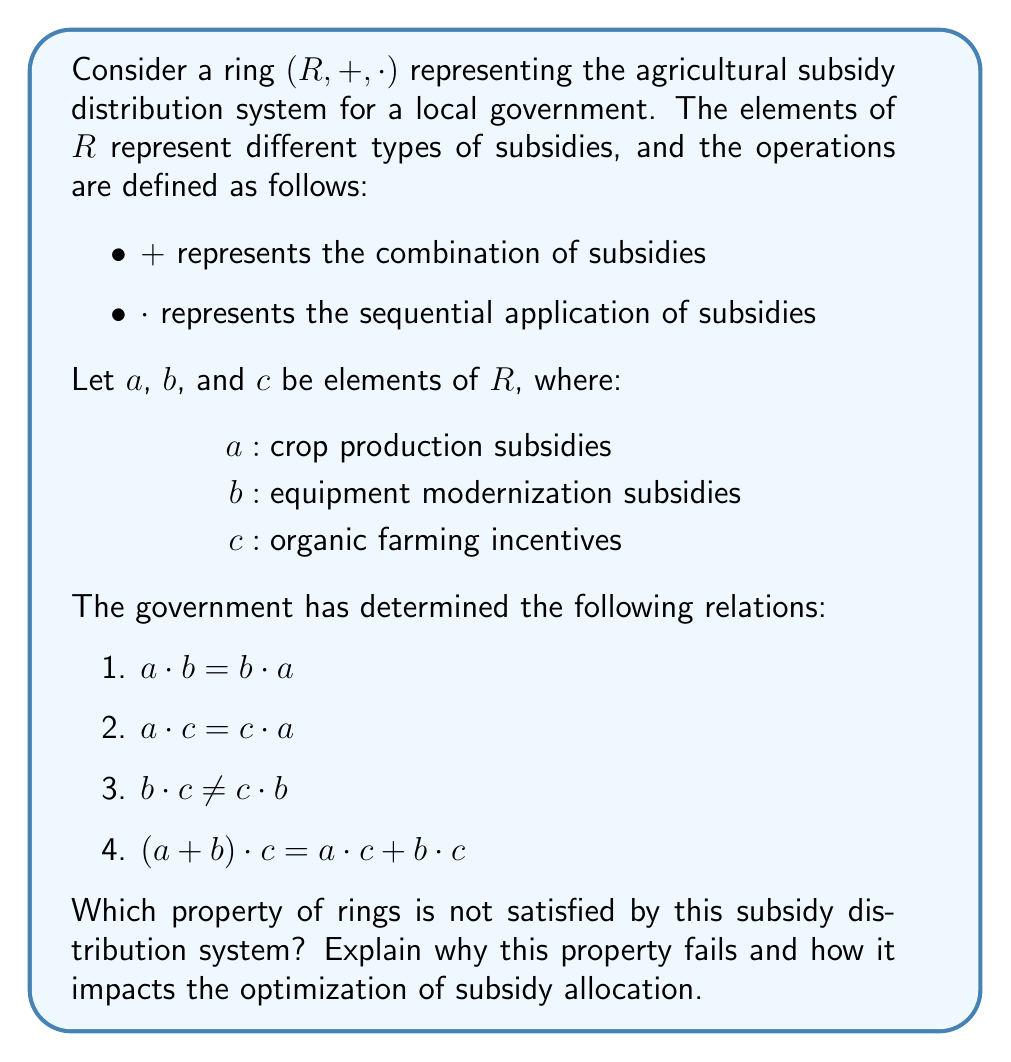Solve this math problem. To determine which ring property is not satisfied, let's review the properties of a ring and check them against the given information:

1. Closure under addition and multiplication: Satisfied (assumed)
2. Associativity of addition and multiplication: Satisfied (assumed)
3. Commutativity of addition: Satisfied (assumed)
4. Existence of additive identity and inverse: Satisfied (assumed)
5. Existence of multiplicative identity: Satisfied (assumed)
6. Distributivity of multiplication over addition: Satisfied (given by relation 4)

The only property left to check is the commutativity of multiplication. From the given relations:

1. $a \cdot b = b \cdot a$ (commutative)
2. $a \cdot c = c \cdot a$ (commutative)
3. $b \cdot c \neq c \cdot b$ (not commutative)

We can see that the commutativity of multiplication does not hold for all elements in the ring, specifically for $b$ and $c$. This means that the order in which equipment modernization subsidies ($b$) and organic farming incentives ($c$) are applied matters and produces different results.

This failure of commutativity impacts the optimization of subsidy allocation because:

1. It introduces complexity in planning subsidy distributions.
2. The effectiveness of subsidies may depend on the order of implementation.
3. It may lead to unintended consequences or inefficiencies in the agricultural sector.
4. It makes it harder to predict and model the overall impact of combined subsidies.

To optimize subsidy allocation, the government official would need to carefully consider the order in which subsidies are applied, especially when combining equipment modernization and organic farming incentives.
Answer: Commutativity of multiplication 